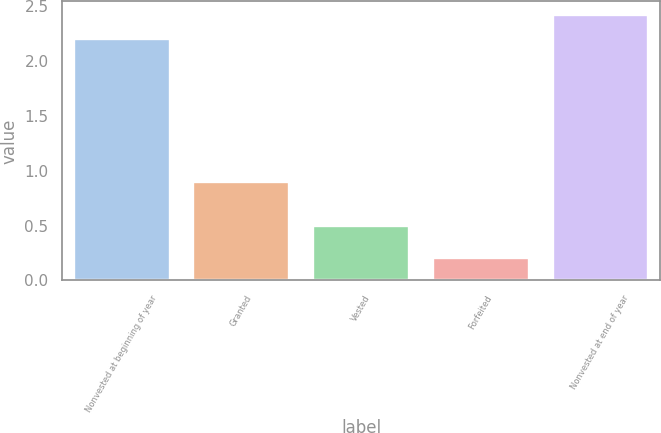Convert chart. <chart><loc_0><loc_0><loc_500><loc_500><bar_chart><fcel>Nonvested at beginning of year<fcel>Granted<fcel>Vested<fcel>Forfeited<fcel>Nonvested at end of year<nl><fcel>2.2<fcel>0.9<fcel>0.5<fcel>0.2<fcel>2.42<nl></chart> 